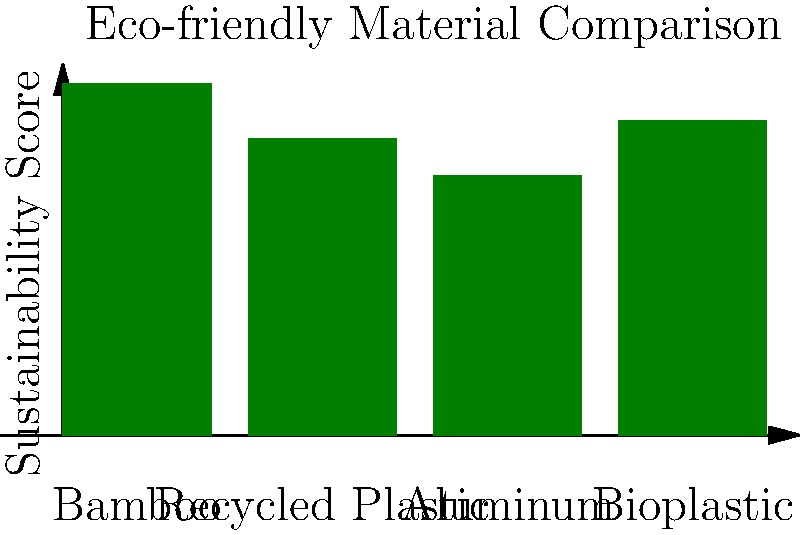Based on the sustainability scores shown in the graph, which material would be the most suitable choice for manufacturing eco-friendly gadgets? To determine the most sustainable material for eco-friendly gadgets, we need to analyze the graph:

1. The graph shows sustainability scores for four materials: Bamboo, Recycled Plastic, Aluminum, and Bioplastic.
2. The y-axis represents the sustainability score, with higher values indicating better sustainability.
3. Comparing the heights of the bars:
   - Bamboo: Approximately 95
   - Recycled Plastic: Approximately 80
   - Aluminum: Approximately 70
   - Bioplastic: Approximately 85
4. The material with the highest sustainability score is the most suitable for eco-friendly gadgets.
5. Bamboo has the highest bar, reaching a score of about 95.

Therefore, based on the visual information provided, Bamboo is the most sustainable material choice for eco-friendly gadgets.
Answer: Bamboo 